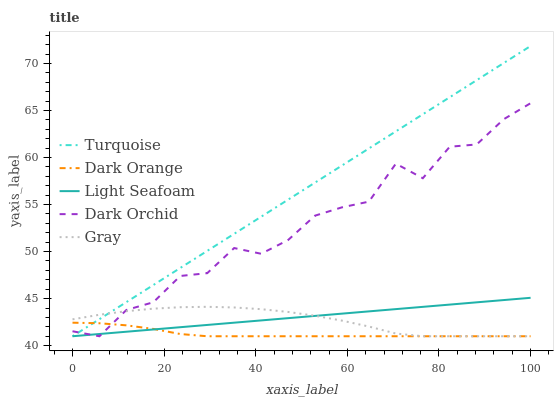Does Dark Orange have the minimum area under the curve?
Answer yes or no. Yes. Does Turquoise have the maximum area under the curve?
Answer yes or no. Yes. Does Light Seafoam have the minimum area under the curve?
Answer yes or no. No. Does Light Seafoam have the maximum area under the curve?
Answer yes or no. No. Is Light Seafoam the smoothest?
Answer yes or no. Yes. Is Dark Orchid the roughest?
Answer yes or no. Yes. Is Turquoise the smoothest?
Answer yes or no. No. Is Turquoise the roughest?
Answer yes or no. No. Does Dark Orange have the lowest value?
Answer yes or no. Yes. Does Turquoise have the highest value?
Answer yes or no. Yes. Does Light Seafoam have the highest value?
Answer yes or no. No. Does Gray intersect Light Seafoam?
Answer yes or no. Yes. Is Gray less than Light Seafoam?
Answer yes or no. No. Is Gray greater than Light Seafoam?
Answer yes or no. No. 